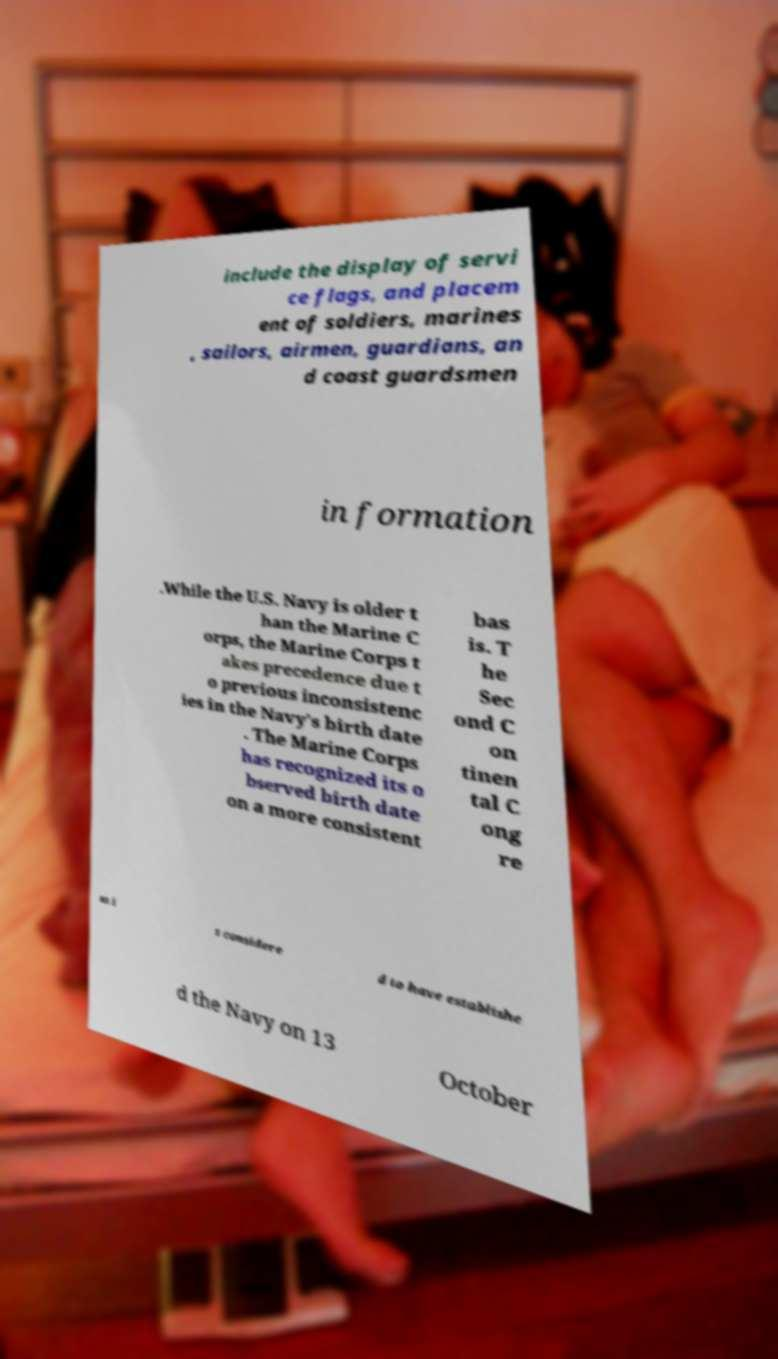There's text embedded in this image that I need extracted. Can you transcribe it verbatim? include the display of servi ce flags, and placem ent of soldiers, marines , sailors, airmen, guardians, an d coast guardsmen in formation .While the U.S. Navy is older t han the Marine C orps, the Marine Corps t akes precedence due t o previous inconsistenc ies in the Navy's birth date . The Marine Corps has recognized its o bserved birth date on a more consistent bas is. T he Sec ond C on tinen tal C ong re ss i s considere d to have establishe d the Navy on 13 October 